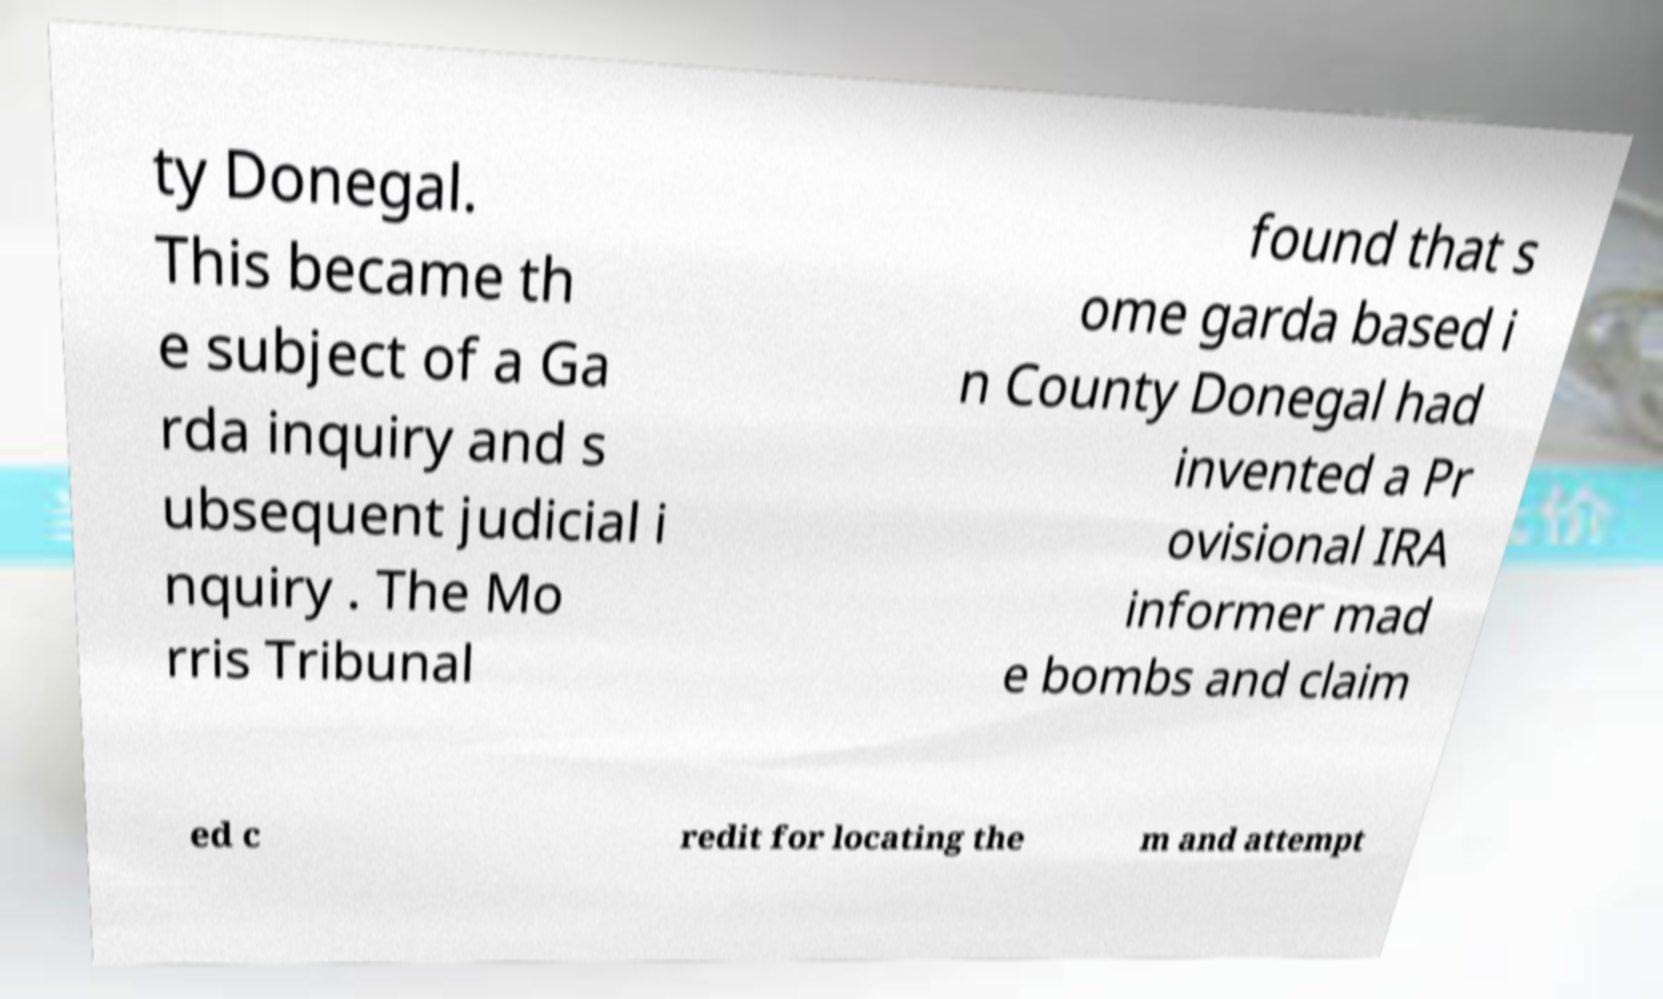There's text embedded in this image that I need extracted. Can you transcribe it verbatim? ty Donegal. This became th e subject of a Ga rda inquiry and s ubsequent judicial i nquiry . The Mo rris Tribunal found that s ome garda based i n County Donegal had invented a Pr ovisional IRA informer mad e bombs and claim ed c redit for locating the m and attempt 